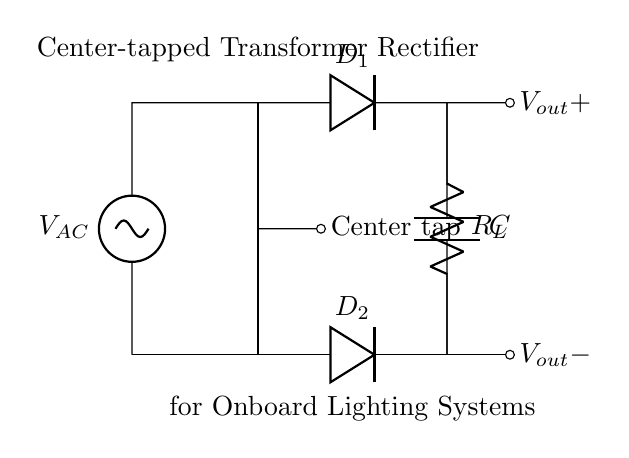What is the type of transformer used in this circuit? The circuit uses a center-tapped transformer, which is indicated by the label and the center tap connection shown in the diagram.
Answer: Center-tapped transformer How many diodes are used in this rectifier? There are two diodes labeled D1 and D2 in the circuit diagram, each connected to different sides of the transformer to form the rectifier.
Answer: Two What is the purpose of the capacitor in this circuit? The capacitor, labeled C, is used to smooth the output voltage by filtering the pulsating DC current produced by the diodes, helping to provide a more stable voltage for the lighting systems.
Answer: Smoothing What is the load connected across the output? A resistor labeled R_L is connected across the output terminals of the rectifier, indicating that it acts as the load for the lighting systems powered by the rectified voltage.
Answer: Resistor What type of current does this rectifier convert? The rectifier converts alternating current (AC) from the transformer into direct current (DC) for powering the onboard lighting systems.
Answer: Alternating current What is the output voltage configuration of the circuit? The output voltage is configured to have a positive voltage at V_out+ and a negative voltage at V_out-, created by the center-tapping of the transformer and the diode connections.
Answer: Positive and negative 